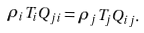<formula> <loc_0><loc_0><loc_500><loc_500>\rho _ { i } T _ { i } Q _ { j i } = \rho _ { j } T _ { j } Q _ { i j } .</formula> 